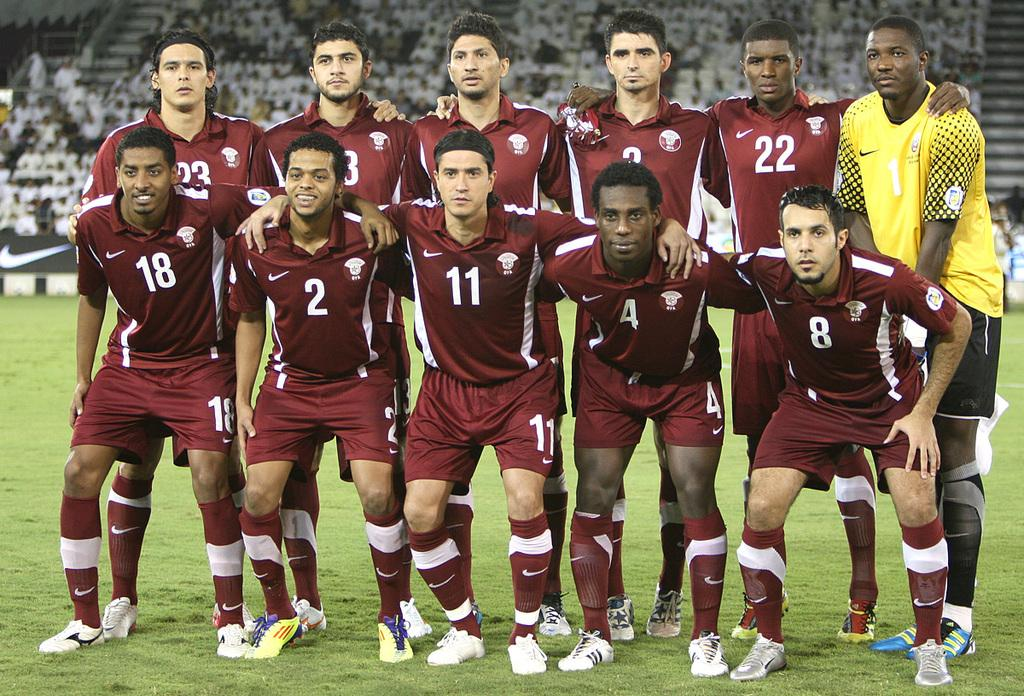Provide a one-sentence caption for the provided image. In a team photo, numbers 18 and 2 are the only ones who smile. 